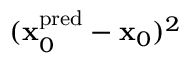Convert formula to latex. <formula><loc_0><loc_0><loc_500><loc_500>( x _ { 0 } ^ { p r e d } - x _ { 0 } ) ^ { 2 }</formula> 